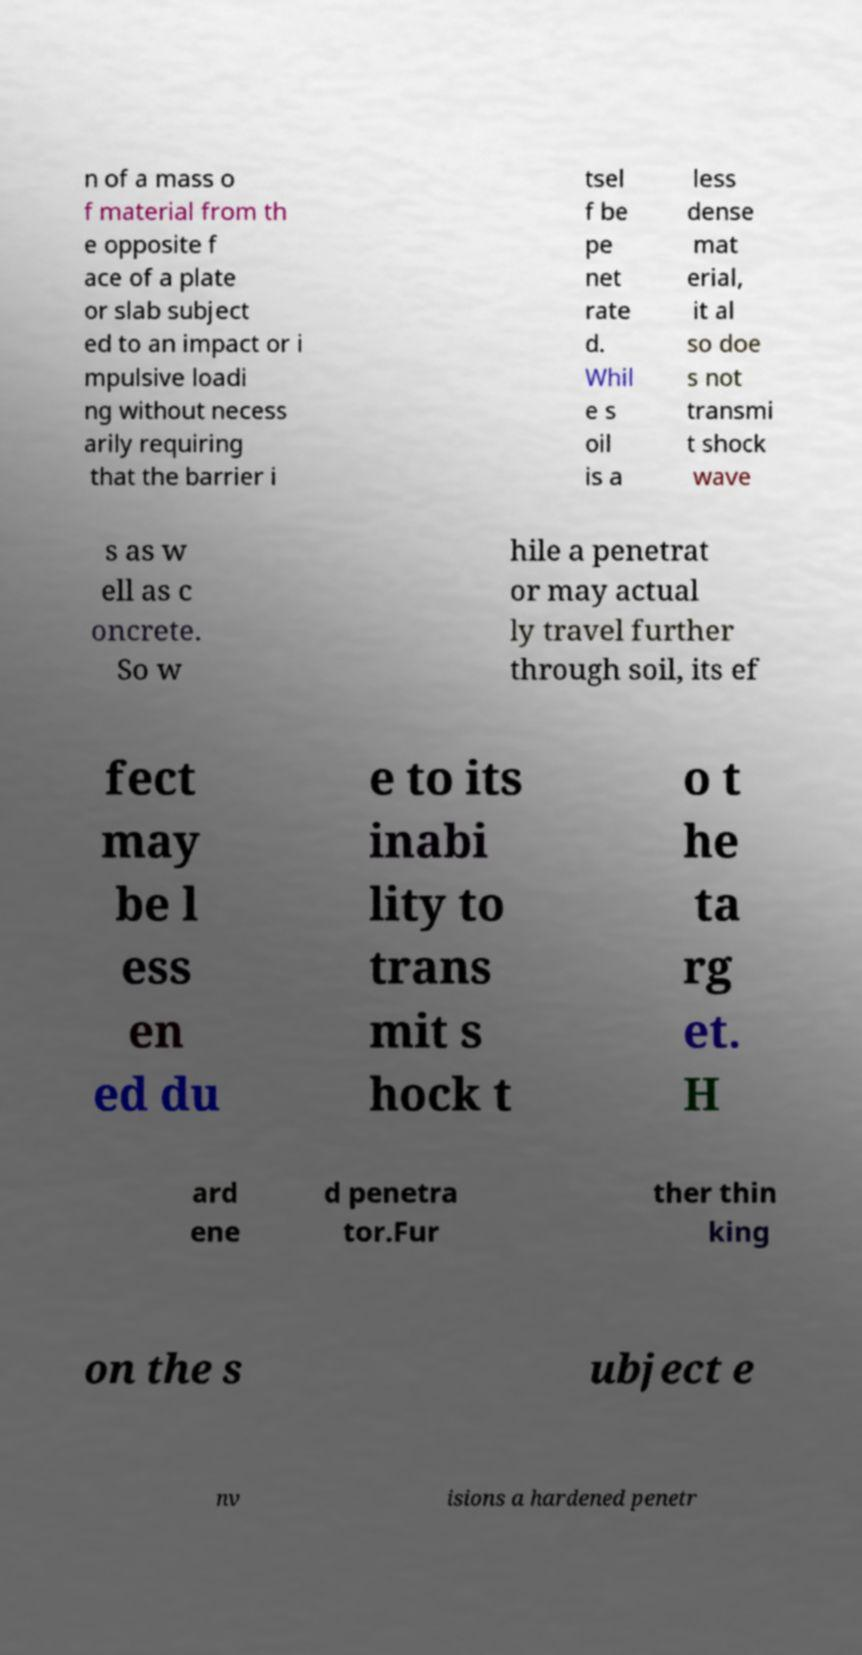For documentation purposes, I need the text within this image transcribed. Could you provide that? n of a mass o f material from th e opposite f ace of a plate or slab subject ed to an impact or i mpulsive loadi ng without necess arily requiring that the barrier i tsel f be pe net rate d. Whil e s oil is a less dense mat erial, it al so doe s not transmi t shock wave s as w ell as c oncrete. So w hile a penetrat or may actual ly travel further through soil, its ef fect may be l ess en ed du e to its inabi lity to trans mit s hock t o t he ta rg et. H ard ene d penetra tor.Fur ther thin king on the s ubject e nv isions a hardened penetr 